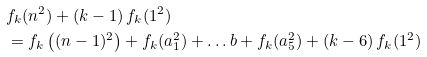Convert formula to latex. <formula><loc_0><loc_0><loc_500><loc_500>& f _ { k } ( n ^ { 2 } ) + ( k - 1 ) \, f _ { k } ( 1 ^ { 2 } ) \\ & = f _ { k } \left ( ( n - 1 ) ^ { 2 } \right ) + f _ { k } ( a _ { 1 } ^ { 2 } ) + \dots b + f _ { k } ( a _ { 5 } ^ { 2 } ) + ( k - 6 ) \, f _ { k } ( 1 ^ { 2 } )</formula> 